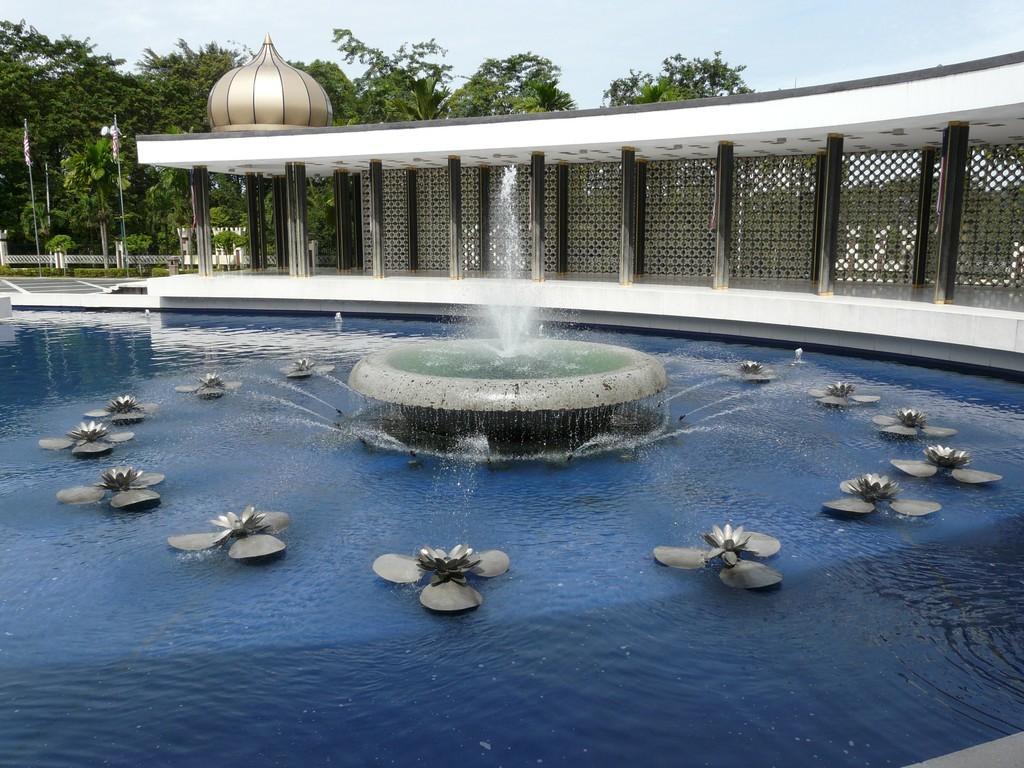Describe this image in one or two sentences. In this image, in the middle, we can see a fountain which is filled with water. On the right side, we can see some pillars. In the background, we can see some flags, trees. At the bottom, we can see water and some flowers. 